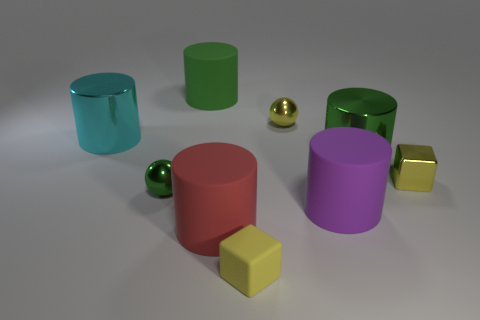Subtract all red cylinders. How many cylinders are left? 4 Subtract all purple cylinders. How many cylinders are left? 4 Subtract all yellow cylinders. Subtract all yellow spheres. How many cylinders are left? 5 Subtract all blocks. How many objects are left? 7 Add 2 large green cylinders. How many large green cylinders exist? 4 Subtract 2 yellow cubes. How many objects are left? 7 Subtract all tiny yellow metal balls. Subtract all yellow blocks. How many objects are left? 6 Add 1 large metallic objects. How many large metallic objects are left? 3 